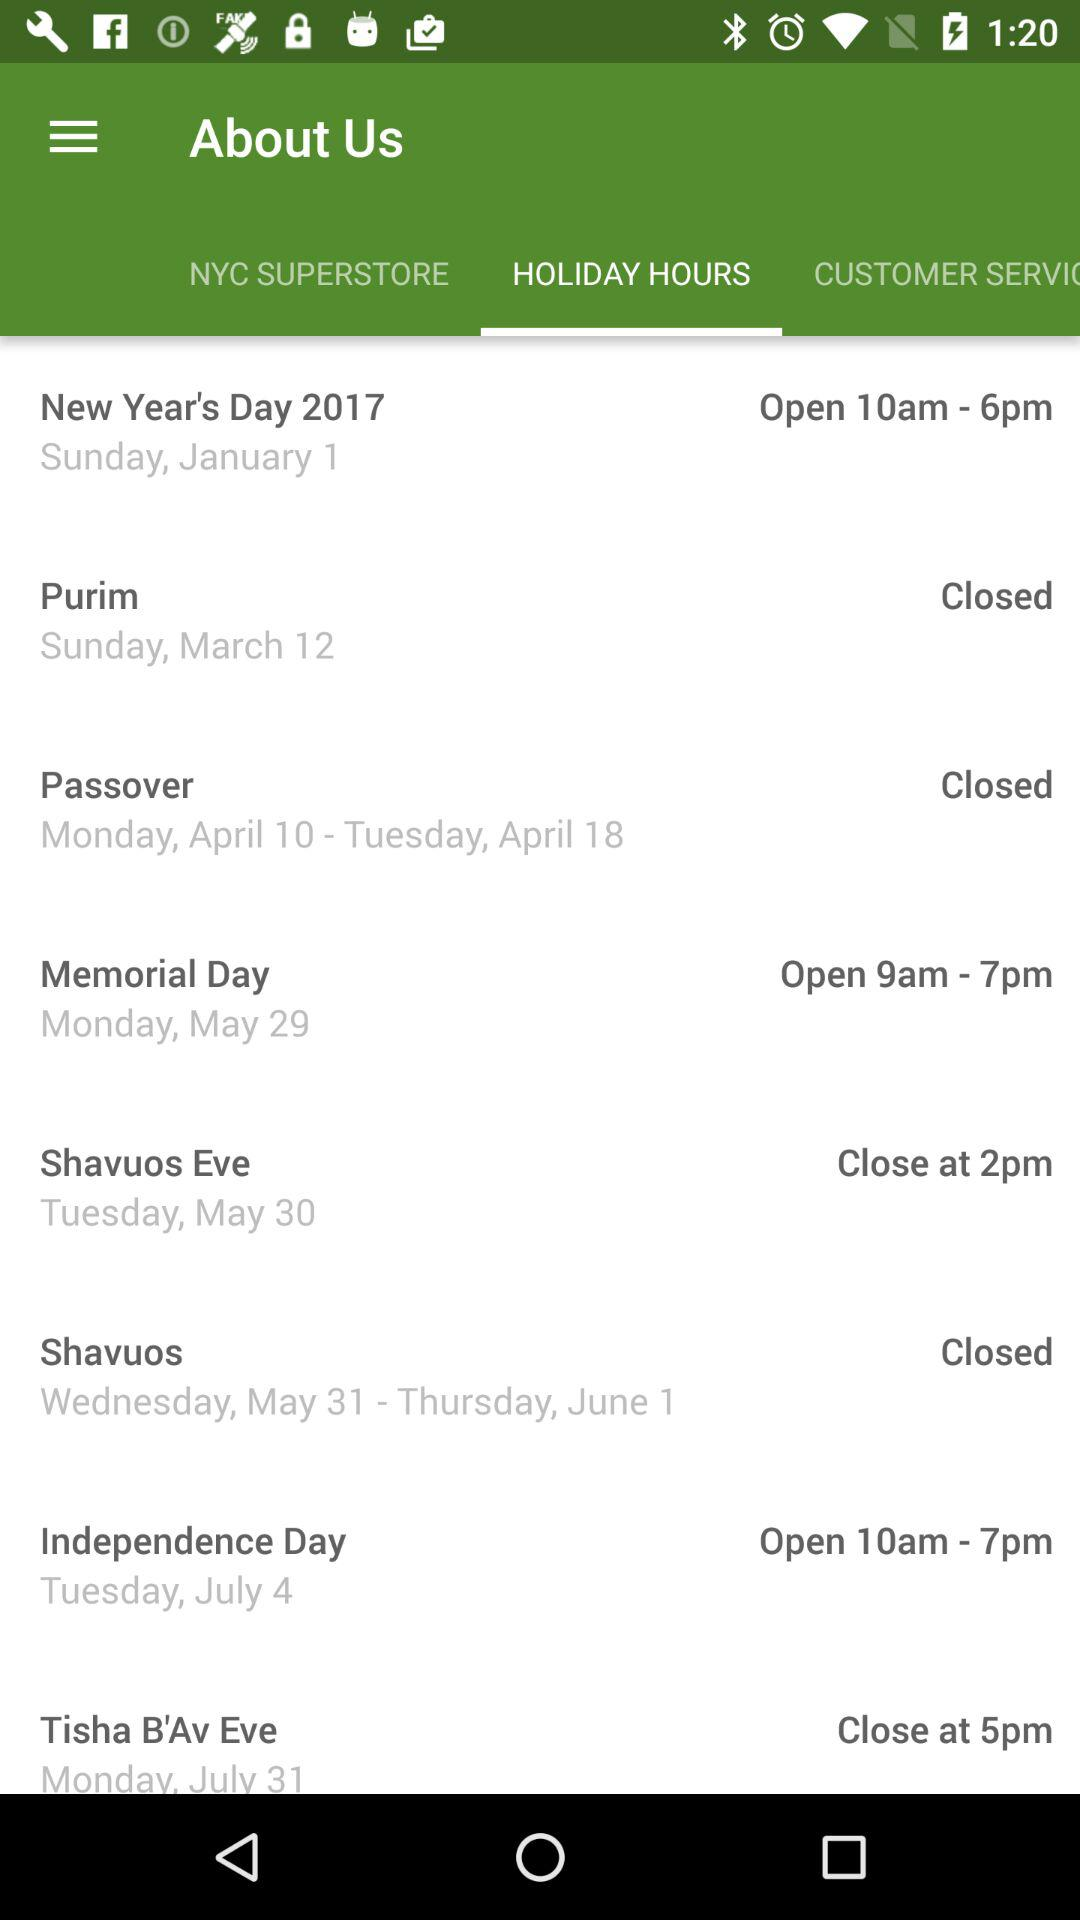Is the store closed on the first day of Hanukkah?
When the provided information is insufficient, respond with <no answer>. <no answer> 